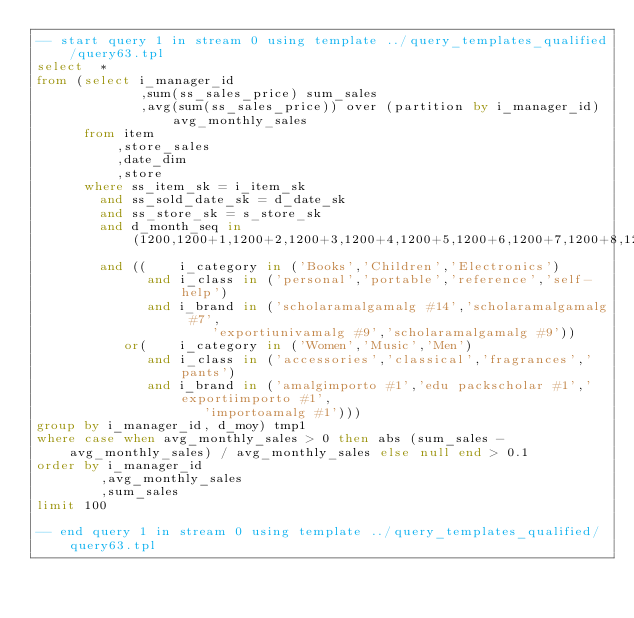Convert code to text. <code><loc_0><loc_0><loc_500><loc_500><_SQL_>-- start query 1 in stream 0 using template ../query_templates_qualified/query63.tpl
select  * 
from (select i_manager_id
             ,sum(ss_sales_price) sum_sales
             ,avg(sum(ss_sales_price)) over (partition by i_manager_id) avg_monthly_sales
      from item
          ,store_sales
          ,date_dim
          ,store
      where ss_item_sk = i_item_sk
        and ss_sold_date_sk = d_date_sk
        and ss_store_sk = s_store_sk
        and d_month_seq in (1200,1200+1,1200+2,1200+3,1200+4,1200+5,1200+6,1200+7,1200+8,1200+9,1200+10,1200+11)
        and ((    i_category in ('Books','Children','Electronics')
              and i_class in ('personal','portable','reference','self-help')
              and i_brand in ('scholaramalgamalg #14','scholaramalgamalg #7',
		                  'exportiunivamalg #9','scholaramalgamalg #9'))
           or(    i_category in ('Women','Music','Men')
              and i_class in ('accessories','classical','fragrances','pants')
              and i_brand in ('amalgimporto #1','edu packscholar #1','exportiimporto #1',
		                 'importoamalg #1')))
group by i_manager_id, d_moy) tmp1
where case when avg_monthly_sales > 0 then abs (sum_sales - avg_monthly_sales) / avg_monthly_sales else null end > 0.1
order by i_manager_id
        ,avg_monthly_sales
        ,sum_sales
limit 100

-- end query 1 in stream 0 using template ../query_templates_qualified/query63.tpl
</code> 